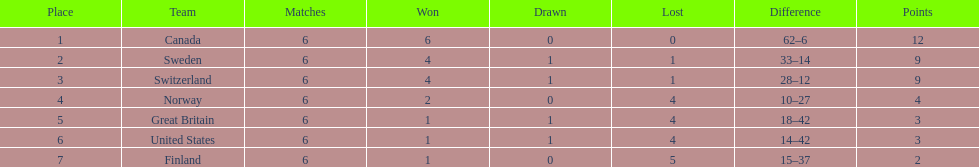Which country had the lowest number of goals conceded? Finland. 